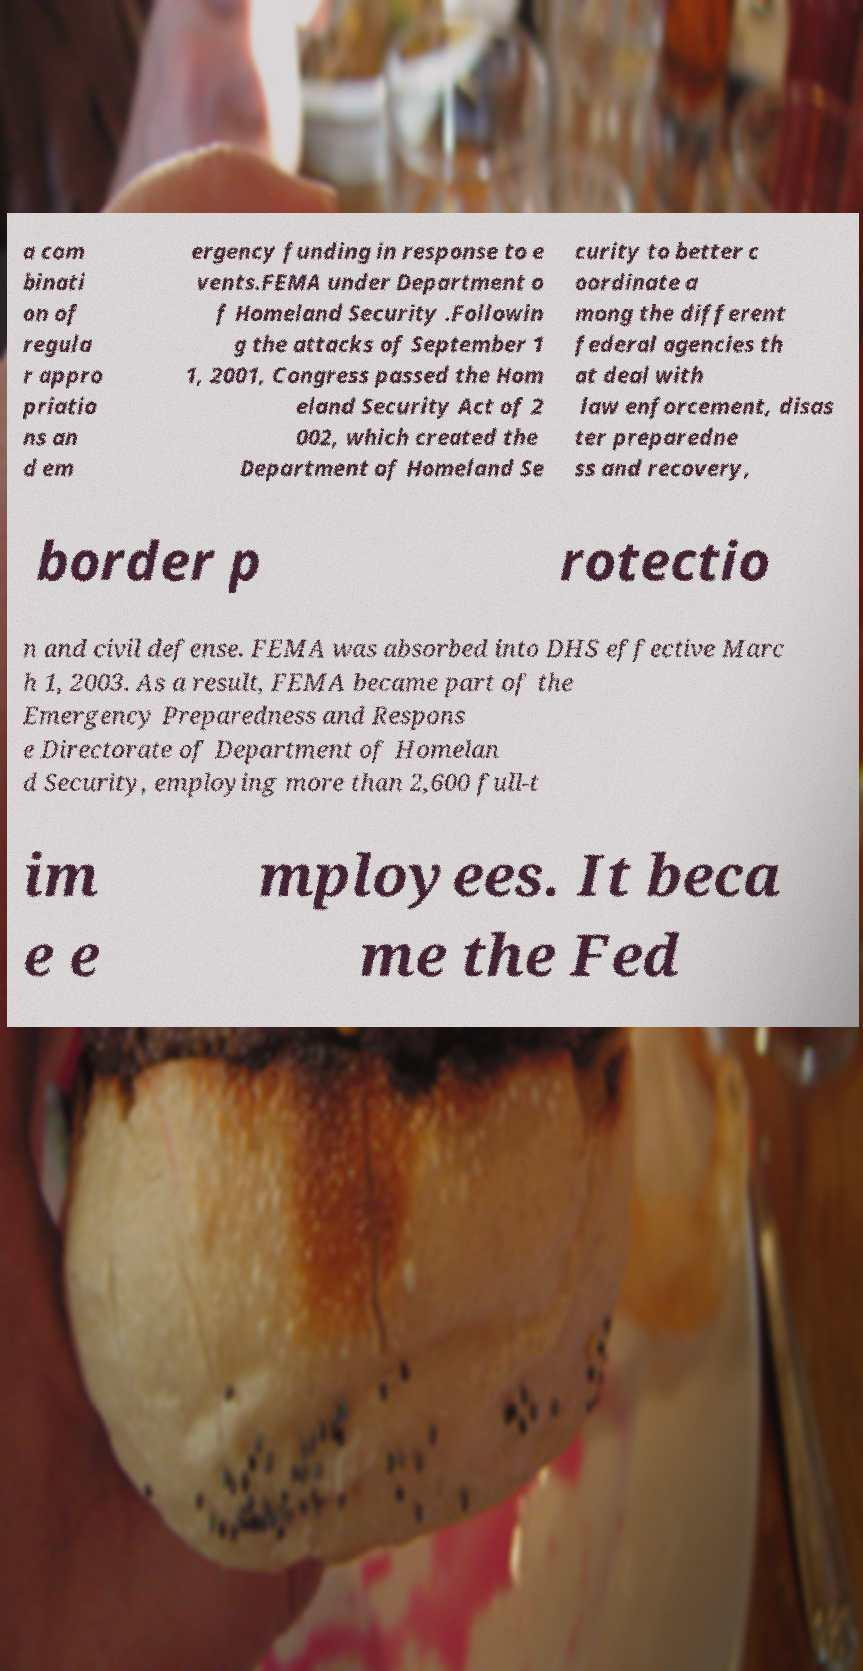For documentation purposes, I need the text within this image transcribed. Could you provide that? a com binati on of regula r appro priatio ns an d em ergency funding in response to e vents.FEMA under Department o f Homeland Security .Followin g the attacks of September 1 1, 2001, Congress passed the Hom eland Security Act of 2 002, which created the Department of Homeland Se curity to better c oordinate a mong the different federal agencies th at deal with law enforcement, disas ter preparedne ss and recovery, border p rotectio n and civil defense. FEMA was absorbed into DHS effective Marc h 1, 2003. As a result, FEMA became part of the Emergency Preparedness and Respons e Directorate of Department of Homelan d Security, employing more than 2,600 full-t im e e mployees. It beca me the Fed 